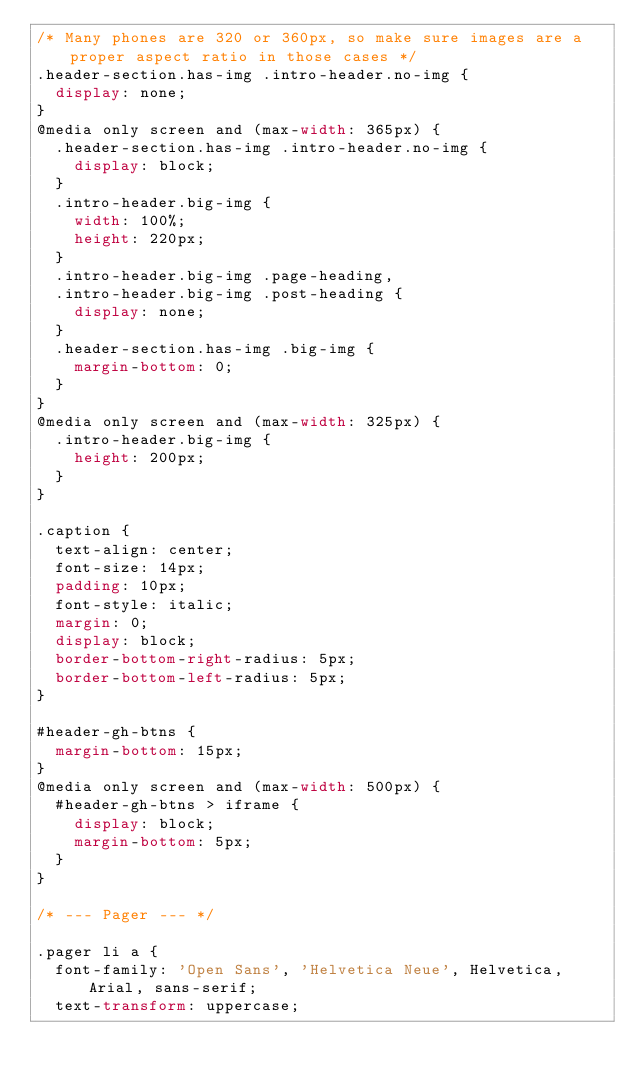Convert code to text. <code><loc_0><loc_0><loc_500><loc_500><_CSS_>/* Many phones are 320 or 360px, so make sure images are a proper aspect ratio in those cases */
.header-section.has-img .intro-header.no-img {
  display: none;
}
@media only screen and (max-width: 365px) {
  .header-section.has-img .intro-header.no-img {
    display: block;
  }
  .intro-header.big-img {
    width: 100%;
    height: 220px;
  }
  .intro-header.big-img .page-heading,
  .intro-header.big-img .post-heading {
    display: none;
  }
  .header-section.has-img .big-img {
    margin-bottom: 0;
  }
}
@media only screen and (max-width: 325px) {
  .intro-header.big-img {
    height: 200px;
  }
}

.caption {
  text-align: center;
  font-size: 14px;
  padding: 10px;
  font-style: italic;
  margin: 0;
  display: block;
  border-bottom-right-radius: 5px;
  border-bottom-left-radius: 5px;
}

#header-gh-btns {
  margin-bottom: 15px;
}
@media only screen and (max-width: 500px) {
  #header-gh-btns > iframe {
    display: block;
    margin-bottom: 5px;
  }
}

/* --- Pager --- */

.pager li a {
  font-family: 'Open Sans', 'Helvetica Neue', Helvetica, Arial, sans-serif;
  text-transform: uppercase;</code> 